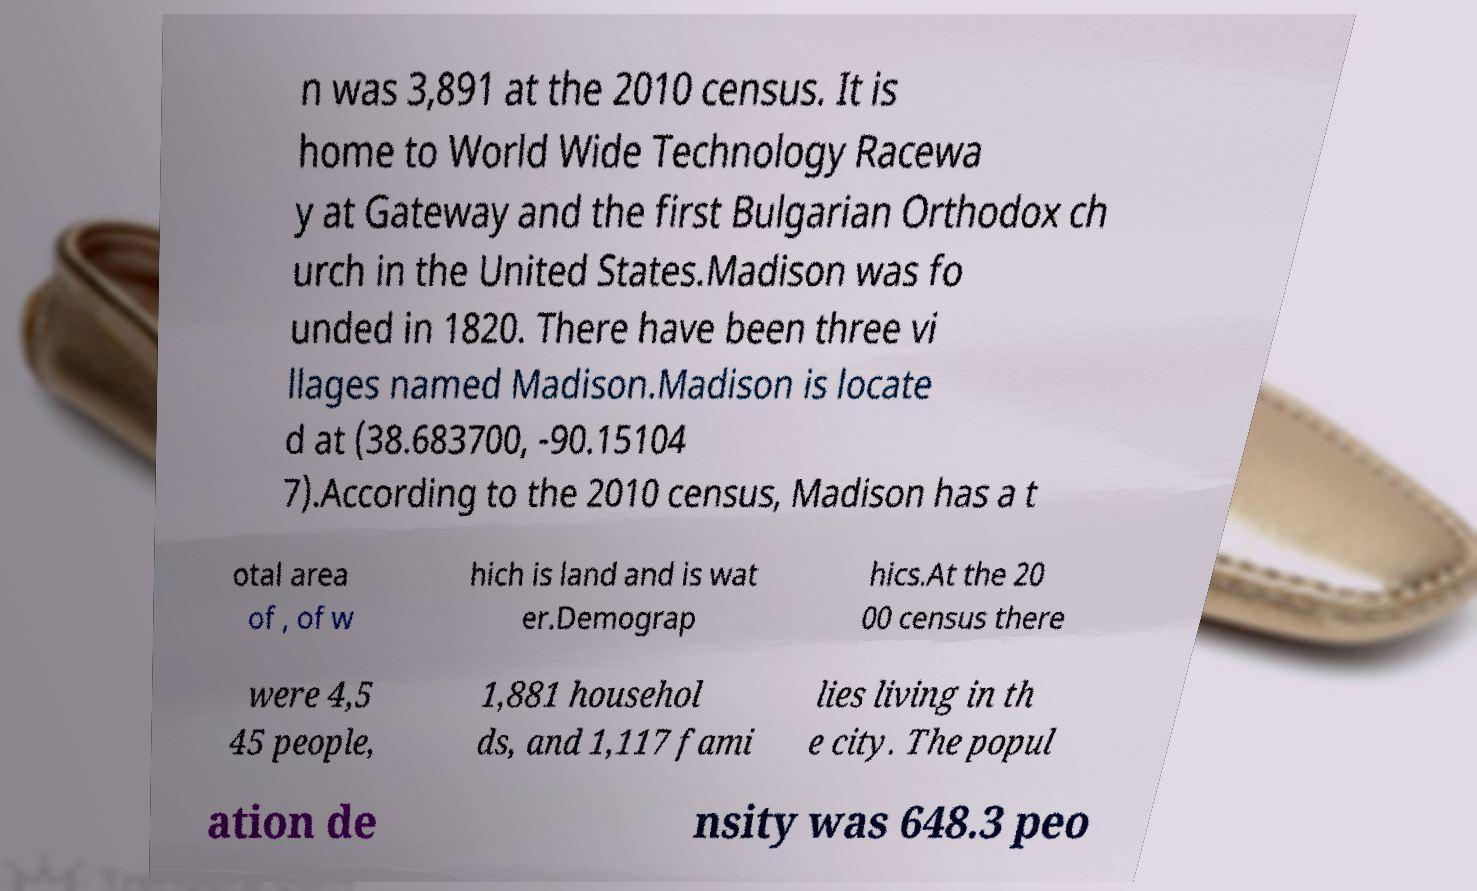There's text embedded in this image that I need extracted. Can you transcribe it verbatim? n was 3,891 at the 2010 census. It is home to World Wide Technology Racewa y at Gateway and the first Bulgarian Orthodox ch urch in the United States.Madison was fo unded in 1820. There have been three vi llages named Madison.Madison is locate d at (38.683700, -90.15104 7).According to the 2010 census, Madison has a t otal area of , of w hich is land and is wat er.Demograp hics.At the 20 00 census there were 4,5 45 people, 1,881 househol ds, and 1,117 fami lies living in th e city. The popul ation de nsity was 648.3 peo 